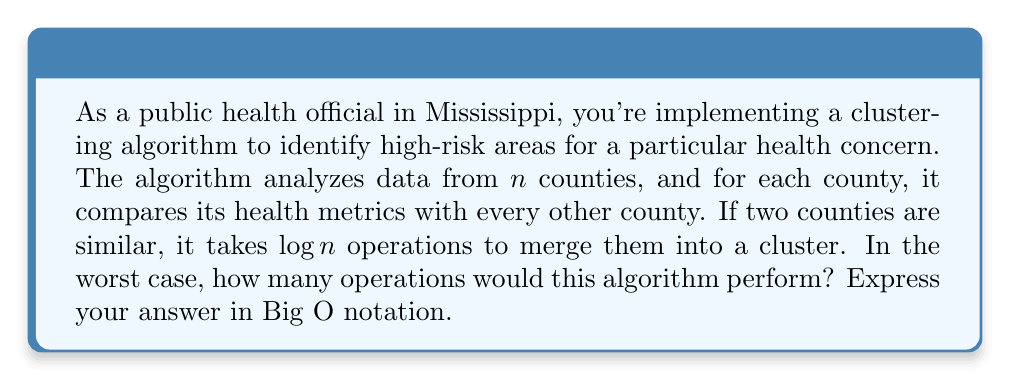Help me with this question. Let's break this down step-by-step:

1) First, we need to understand what the algorithm is doing:
   - It's comparing each county with every other county
   - For similar counties, it performs a merge operation

2) To compare each county with every other county:
   - We have $n$ counties
   - Each county is compared with $(n-1)$ other counties
   - This results in $\frac{n(n-1)}{2}$ comparisons
   - This is because we don't need to compare a county with itself, and we don't need to repeat comparisons

3) In the worst case scenario, every comparison could result in a merge:
   - Each merge operation takes $\log n$ time
   - So, in the worst case, we have $\frac{n(n-1)}{2}$ merge operations
   - Each merge operation takes $\log n$ time

4) Therefore, the total number of operations in the worst case would be:
   $$\frac{n(n-1)}{2} \cdot \log n$$

5) Simplifying this expression:
   $$\frac{n^2 \log n - n \log n}{2}$$

6) In Big O notation, we focus on the dominant term as $n$ grows large:
   - $n^2 \log n$ grows faster than $n \log n$
   - The constant factor of $\frac{1}{2}$ is ignored in Big O notation

7) Therefore, the runtime complexity in Big O notation is $O(n^2 \log n)$
Answer: $O(n^2 \log n)$ 